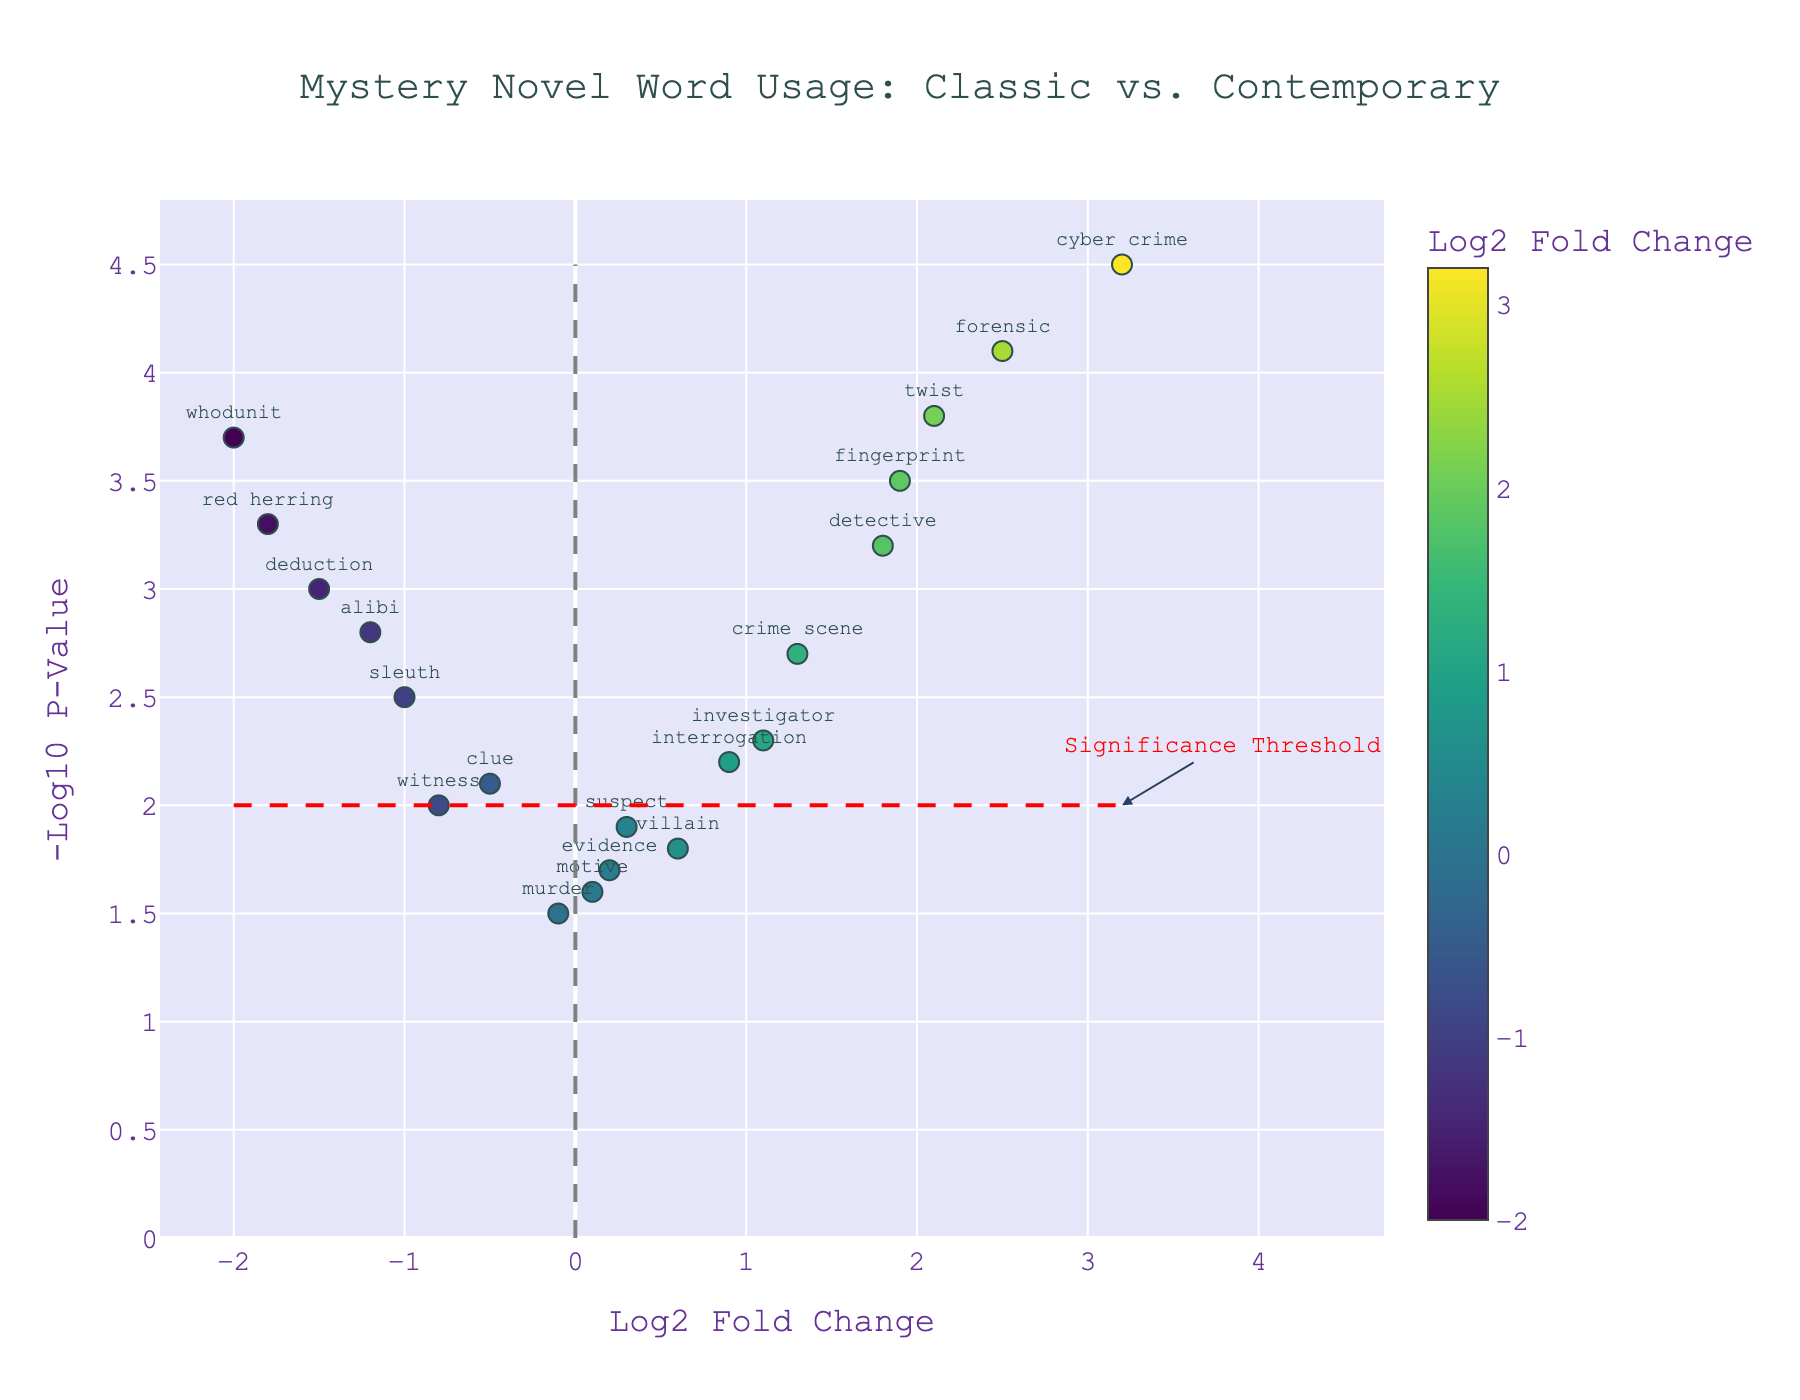How many data points (words) are there in the plot? Count the number of markers representing words in the plot. There are 20 words listed in the provided data.
Answer: 20 What is the title of the plot? Read the title text at the top center of the plot. The title is "Mystery Novel Word Usage: Classic vs. Contemporary".
Answer: Mystery Novel Word Usage: Classic vs. Contemporary Which word has the highest significance (NegativeLog10PValue)? Identify the marker with the highest y-axis value. "Cyber crime" has the highest y-axis value of 4.5.
Answer: Cyber crime What are the respective Log2 Fold Change and -Log10 P-Value for the word "forensic"? Look at the position of the word "forensic" on the plot and note its coordinates. The respective values are Log2 Fold Change: 2.5 and -Log10 P-Value: 4.1.
Answer: Log2 Fold Change: 2.5, -Log10 P-Value: 4.1 Which word is equally or more significant (NegativeLog10PValue) than the significance threshold (2)? Find markers with y-axis values of 2 or higher. Words: "detective," "clue," "alibi," "forensic," "investigator," "witness," "deduction," "fingerprint," "interrogation," "red herring," "sleuth," "crime scene," "twist," "whodunit," "cyber crime".
Answer: detective, clue, alibi, forensic, investigator, witness, deduction, fingerprint, interrogation, red herring, sleuth, crime scene, twist, whodunit, cyber crime How many words have a negative Log2 Fold Change? Count the number of markers on the left side of the vertical line x=0. Words: "clue," "alibi," "murder," "witness," "deduction," "red herring," "sleuth," "whodunit".
Answer: 8 Which word has the largest positive difference in Log2 Fold Change compared to "red herring"? The Log2 Fold Change of "red herring" is -1.8. Find the word with the largest positive difference compared to -1.8. "Cyber crime" has Log2 Fold Change of 3.2 which is the largest positive difference (3.2 - (-1.8) = 5).
Answer: Cyber crime What is the overall trend for words with high -Log10 P-Value? Observe the plot for words with high y-axis values and note their x-axis values. Generally, words with high -Log10 P-Value tend to have more extreme Log2 Fold Change values, either strongly positive or negative.
Answer: Extreme Log2 Fold Change values 